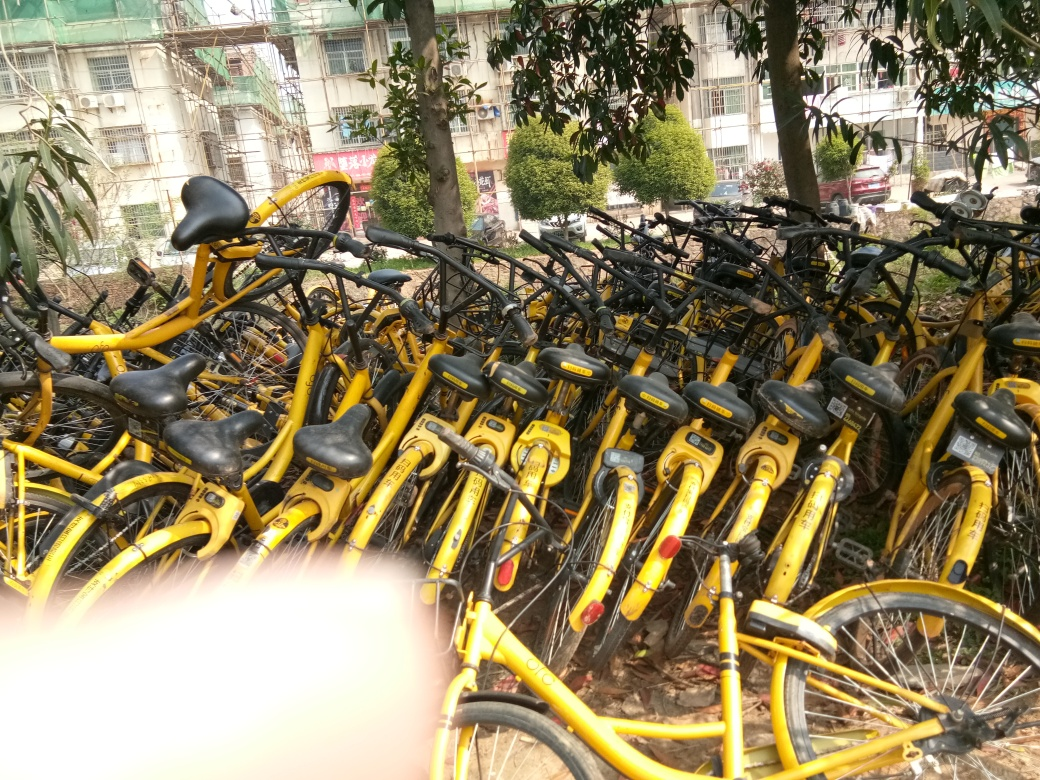What can you tell me about the condition of these bicycles? These bicycles appear to be in varying conditions. Some look well-maintained and ready for use, while others show signs of wear, such as bent wheels or frames. The dense arrangement suggests they might be part of a bike-sharing service awaiting maintenance or redistribution. 